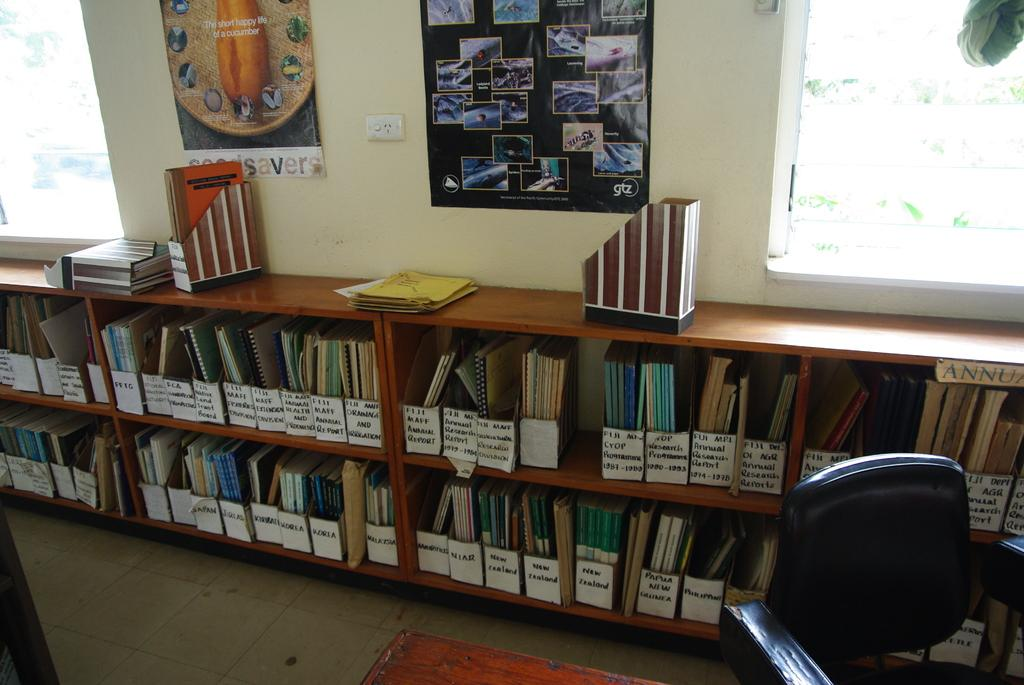What type of furniture is present in the image? There is a wooden bookshelf in the image. What is stored on the wooden bookshelf? Books are arranged on the bookshelf. What piece of furniture is located on the right side of the image? There is a chair on the right side of the image. Is there any source of natural light in the image? Yes, there is a window in the image. What type of peace can be felt in the image? The image does not convey a sense of peace or emotion; it is a static representation of furniture and a window. 